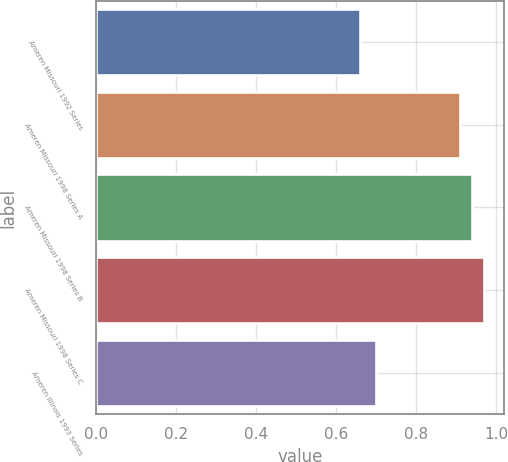Convert chart. <chart><loc_0><loc_0><loc_500><loc_500><bar_chart><fcel>Ameren Missouri 1992 Series<fcel>Ameren Missouri 1998 Series A<fcel>Ameren Missouri 1998 Series B<fcel>Ameren Missouri 1998 Series C<fcel>Ameren Illinois 1993 Series<nl><fcel>0.66<fcel>0.91<fcel>0.94<fcel>0.97<fcel>0.7<nl></chart> 